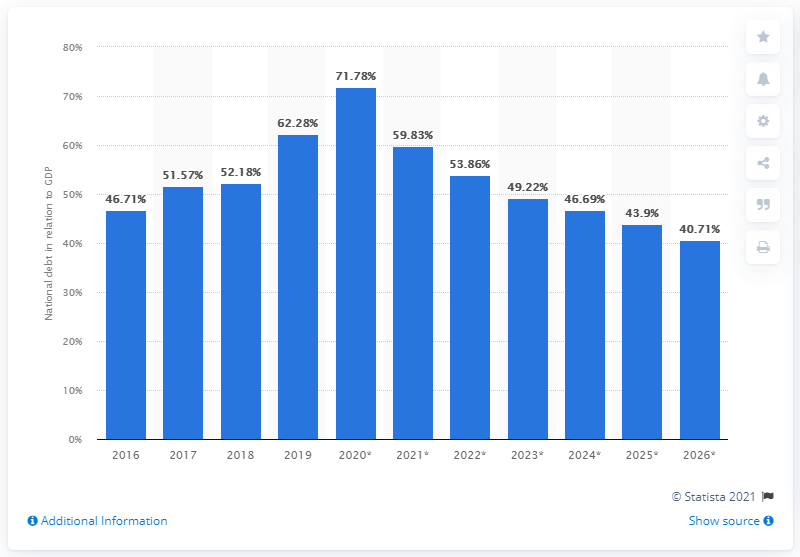Highlight a few significant elements in this photo. In 2019, 62.28% of Qatar's GDP was accounted for by its national debt. 